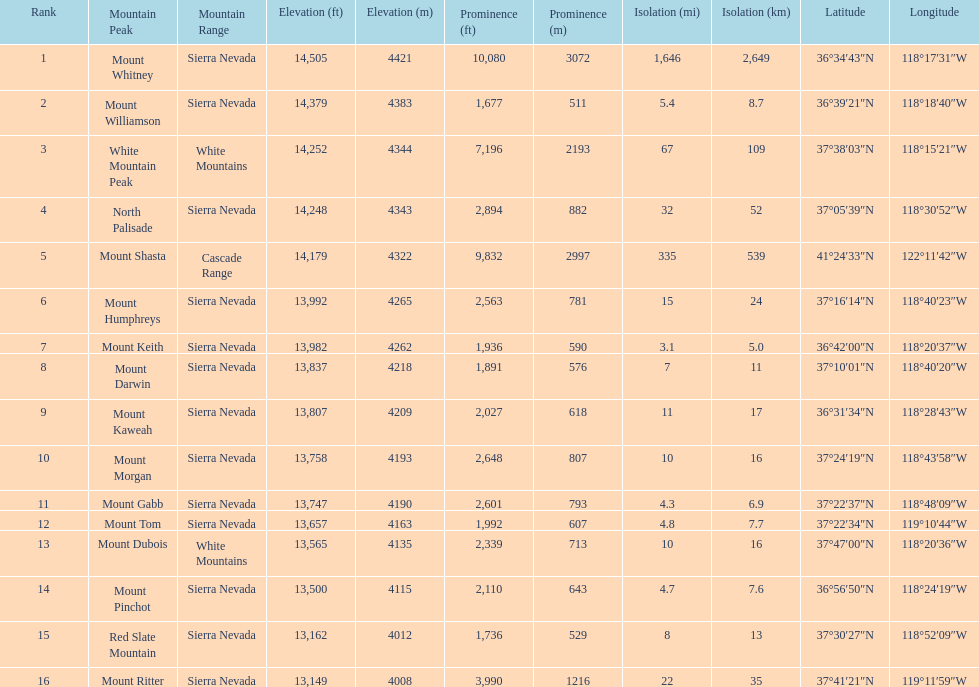Which mountain peak is the only mountain peak in the cascade range? Mount Shasta. 